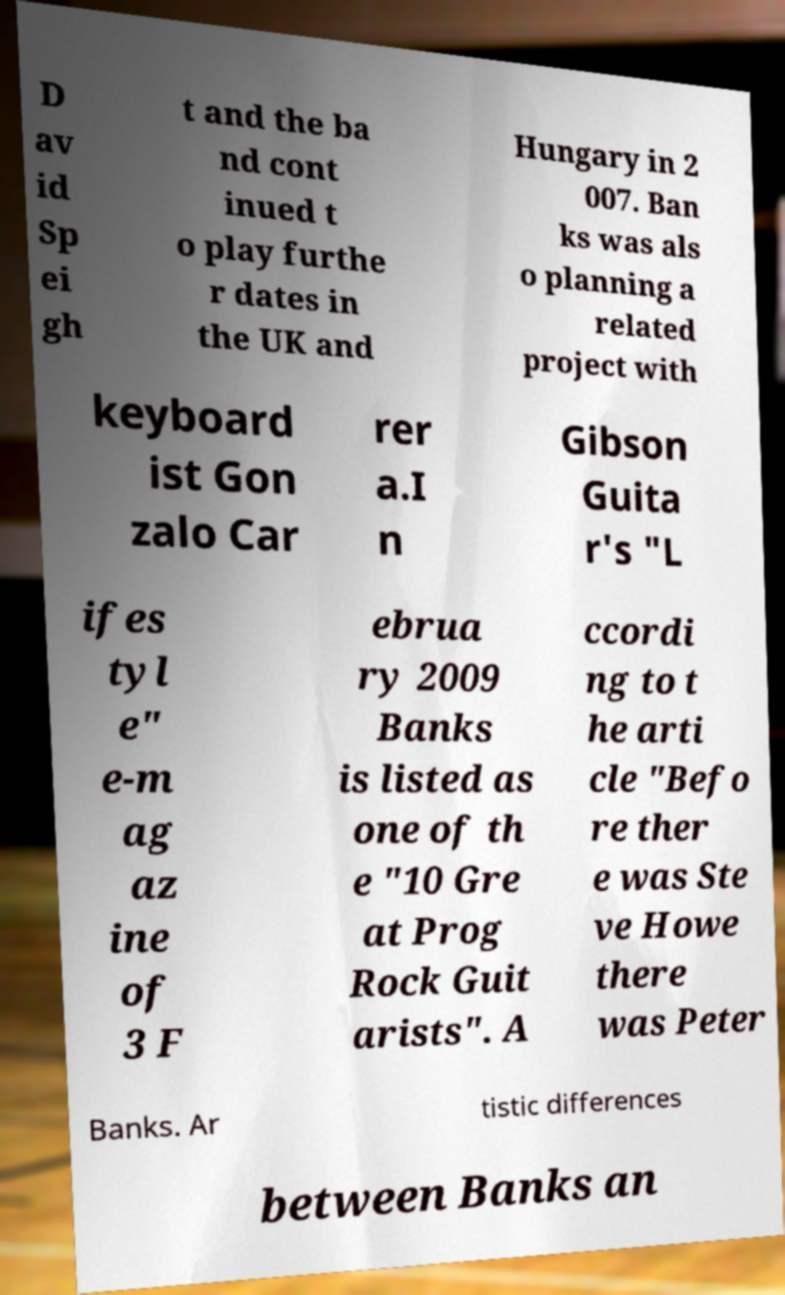Could you extract and type out the text from this image? D av id Sp ei gh t and the ba nd cont inued t o play furthe r dates in the UK and Hungary in 2 007. Ban ks was als o planning a related project with keyboard ist Gon zalo Car rer a.I n Gibson Guita r's "L ifes tyl e" e-m ag az ine of 3 F ebrua ry 2009 Banks is listed as one of th e "10 Gre at Prog Rock Guit arists". A ccordi ng to t he arti cle "Befo re ther e was Ste ve Howe there was Peter Banks. Ar tistic differences between Banks an 